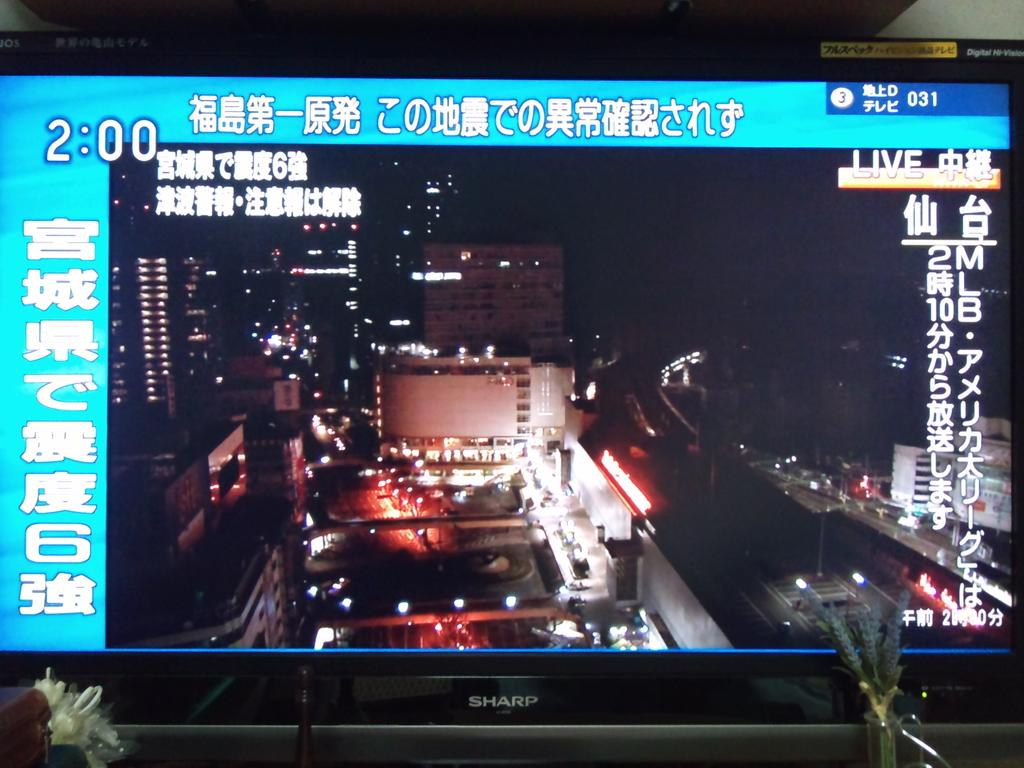<image>
Render a clear and concise summary of the photo. A close up of a Sharp flat screen TV which shows a city scene srrounded by Chinese writing. 